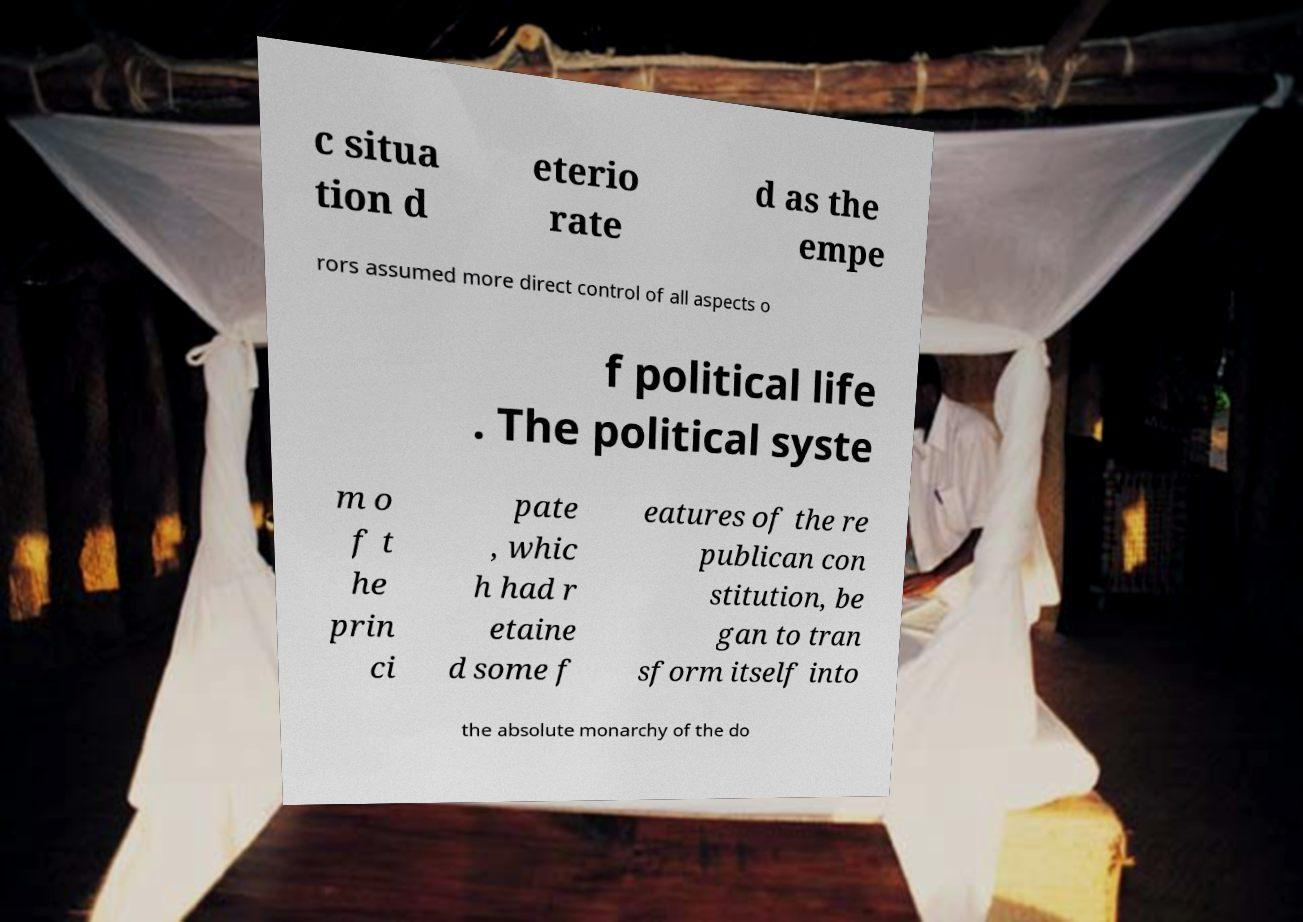For documentation purposes, I need the text within this image transcribed. Could you provide that? c situa tion d eterio rate d as the empe rors assumed more direct control of all aspects o f political life . The political syste m o f t he prin ci pate , whic h had r etaine d some f eatures of the re publican con stitution, be gan to tran sform itself into the absolute monarchy of the do 